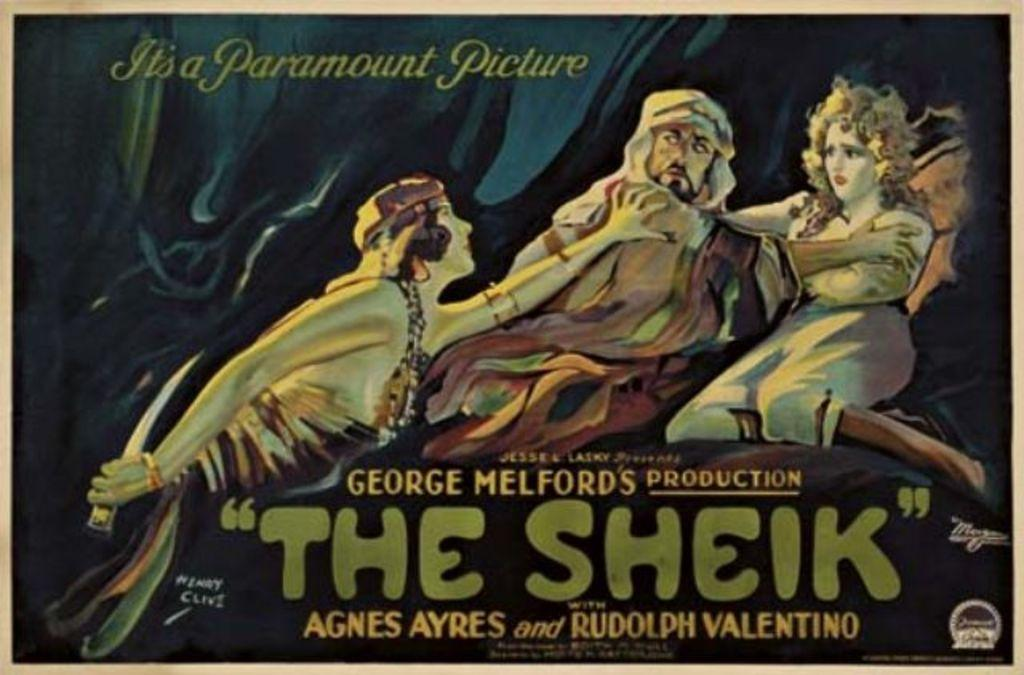Provide a one-sentence caption for the provided image. It's a paramount picture of the Sheik a george melford's production. 